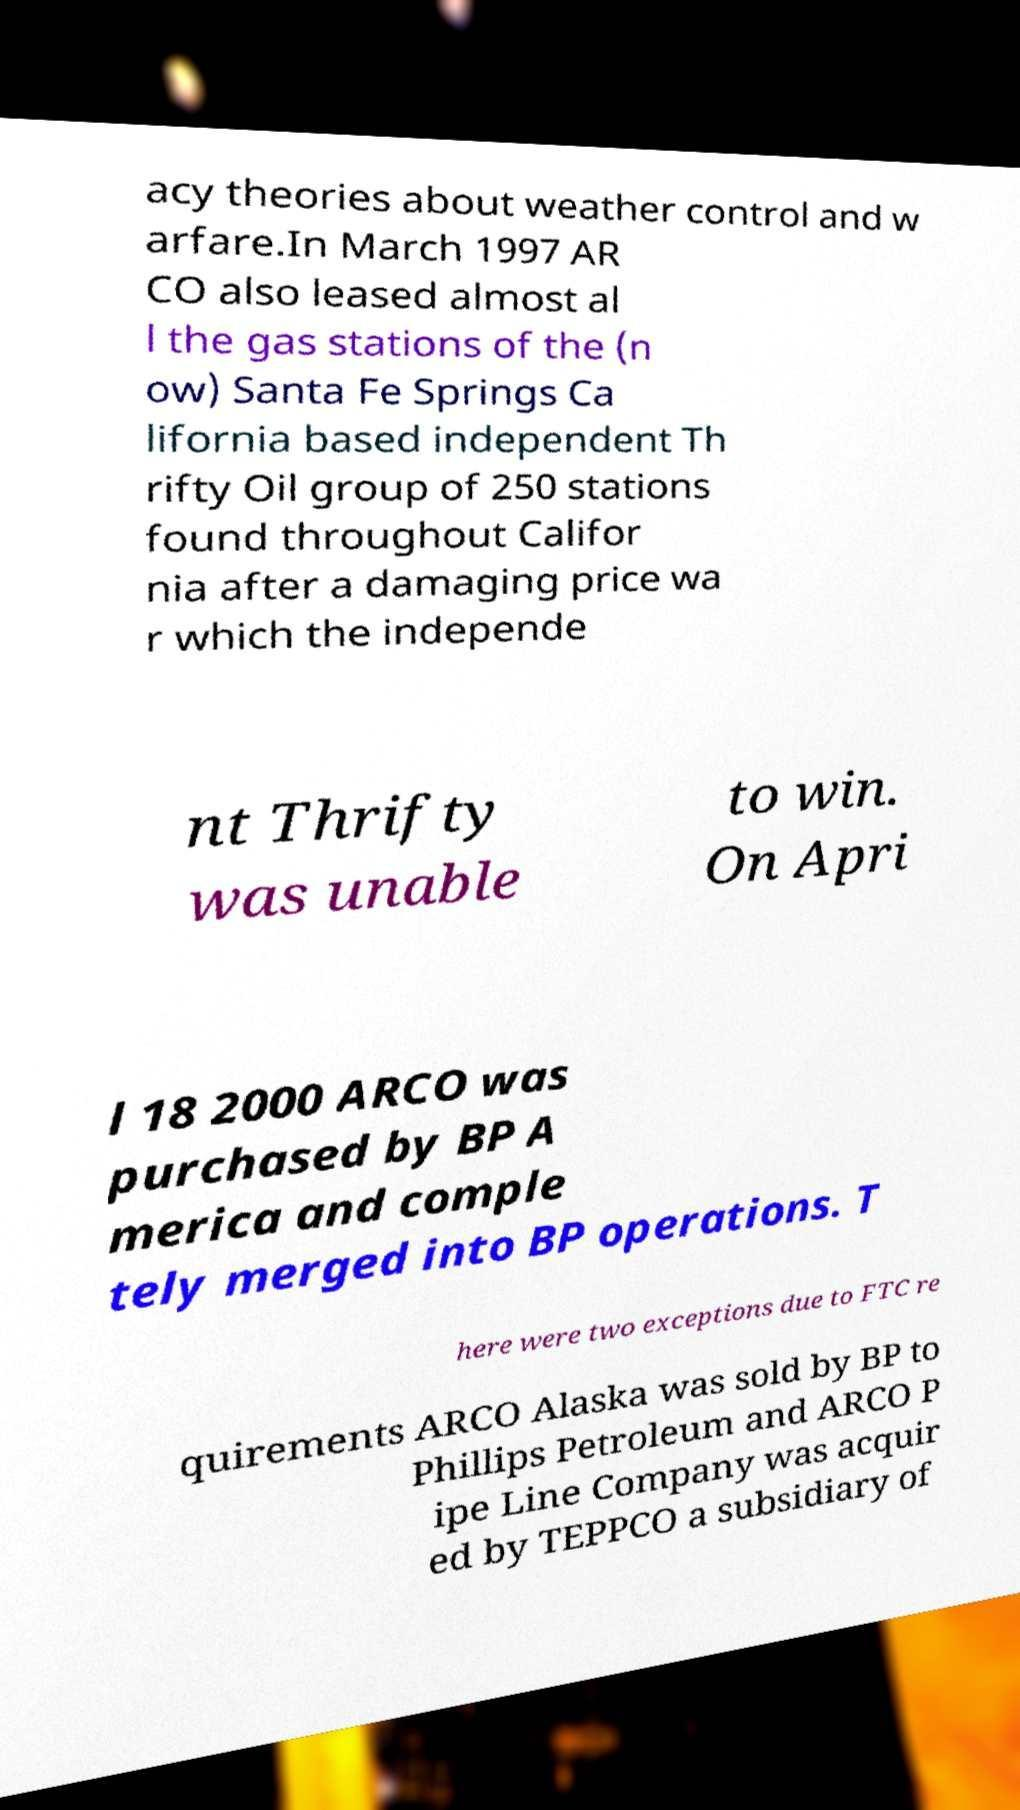Could you assist in decoding the text presented in this image and type it out clearly? acy theories about weather control and w arfare.In March 1997 AR CO also leased almost al l the gas stations of the (n ow) Santa Fe Springs Ca lifornia based independent Th rifty Oil group of 250 stations found throughout Califor nia after a damaging price wa r which the independe nt Thrifty was unable to win. On Apri l 18 2000 ARCO was purchased by BP A merica and comple tely merged into BP operations. T here were two exceptions due to FTC re quirements ARCO Alaska was sold by BP to Phillips Petroleum and ARCO P ipe Line Company was acquir ed by TEPPCO a subsidiary of 